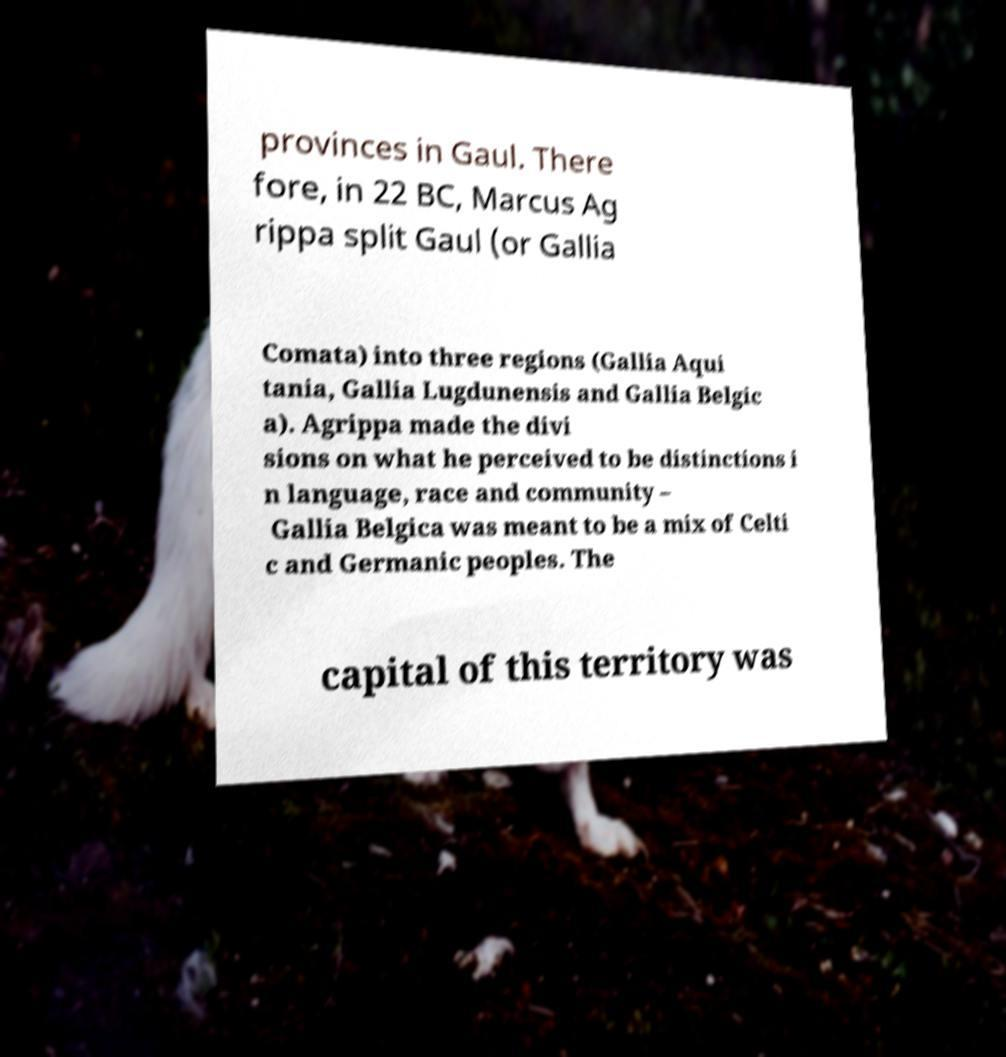I need the written content from this picture converted into text. Can you do that? provinces in Gaul. There fore, in 22 BC, Marcus Ag rippa split Gaul (or Gallia Comata) into three regions (Gallia Aqui tania, Gallia Lugdunensis and Gallia Belgic a). Agrippa made the divi sions on what he perceived to be distinctions i n language, race and community – Gallia Belgica was meant to be a mix of Celti c and Germanic peoples. The capital of this territory was 